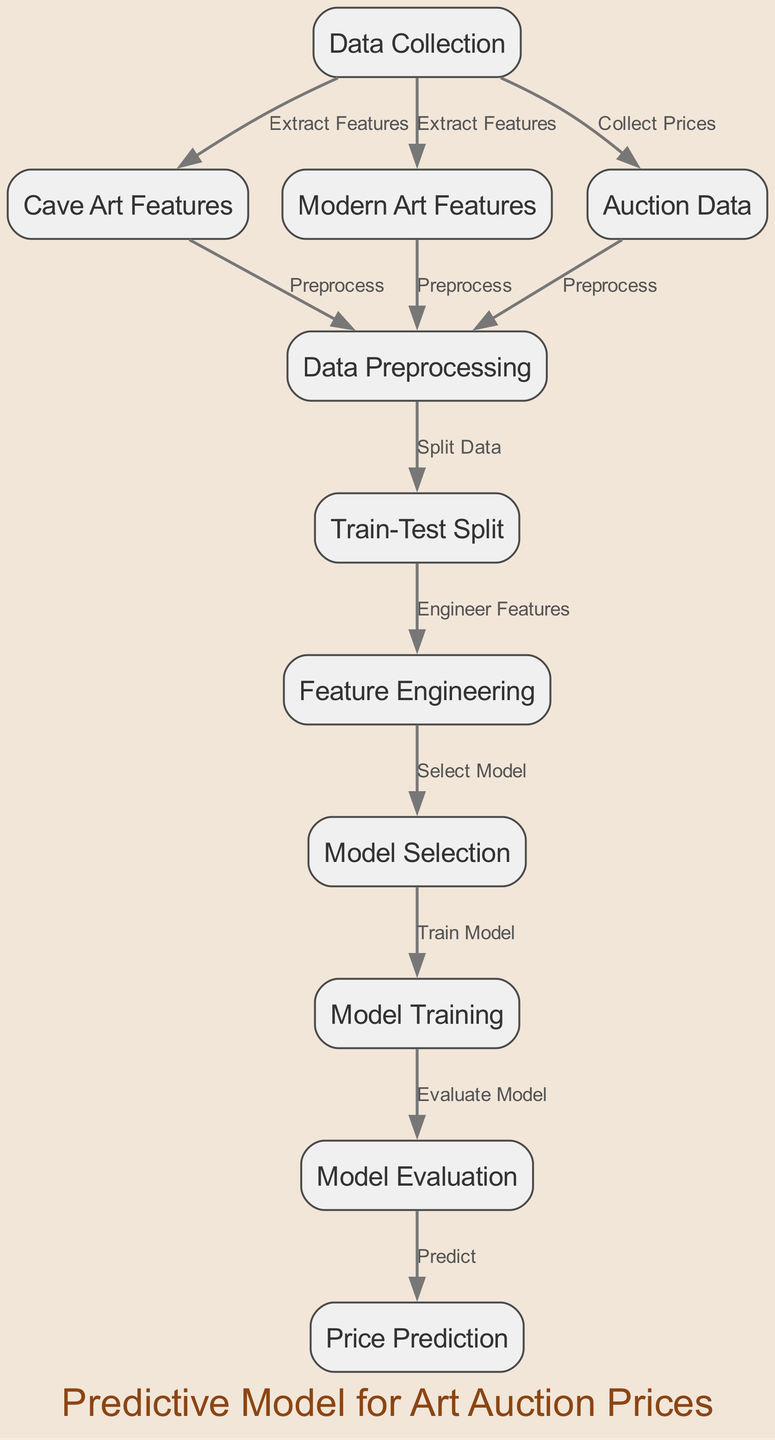What is the first node in the diagram? The first node in the diagram represents the initial step in the process, which is "Data Collection." It is the starting point from where the flow begins.
Answer: Data Collection How many nodes are in the diagram? By counting all the unique nodes listed, including the main processes and features involved, there are a total of eleven nodes in the diagram.
Answer: Eleven What is the connection between 'Cave Art Features' and 'Data Preprocessing'? The connection is that 'Cave Art Features' is processed in the 'Data Preprocessing' node, indicating that features extracted from cave art are prepared for analysis.
Answer: Preprocess Which node comes after 'Model Selection'? The node that follows 'Model Selection' in the flow of the diagram is 'Model Training,' which signifies that once a model is selected, it needs to be trained on the data.
Answer: Model Training What is the final output of the diagram? The final output after going through all the processes in the diagram is 'Price Prediction,' meaning that the model predicts auction prices based on the previous steps.
Answer: Price Prediction How does 'Feature Engineering' relate to 'Train-Test Split'? After completing the 'Train-Test Split' stage, 'Feature Engineering' is the next step, indicating that features are modified or enhanced using the split data before training the model.
Answer: Engineer Features What type of data is collected in 'Auction Data'? The 'Auction Data' node specifically collects the prices of the art pieces sold at auctions, providing essential information for the model.
Answer: Collect Prices Which node receives inputs from both 'Modern Art Features' and 'Cave Art Features'? The node that receives inputs from both 'Modern Art Features' and 'Cave Art Features' is 'Data Preprocessing,' which processes information gathered from both types of art.
Answer: Data Preprocessing How many edges are in the diagram? By counting all the connections between the nodes, there are thirteen edges in the diagram indicating the relationships between the different steps.
Answer: Thirteen 